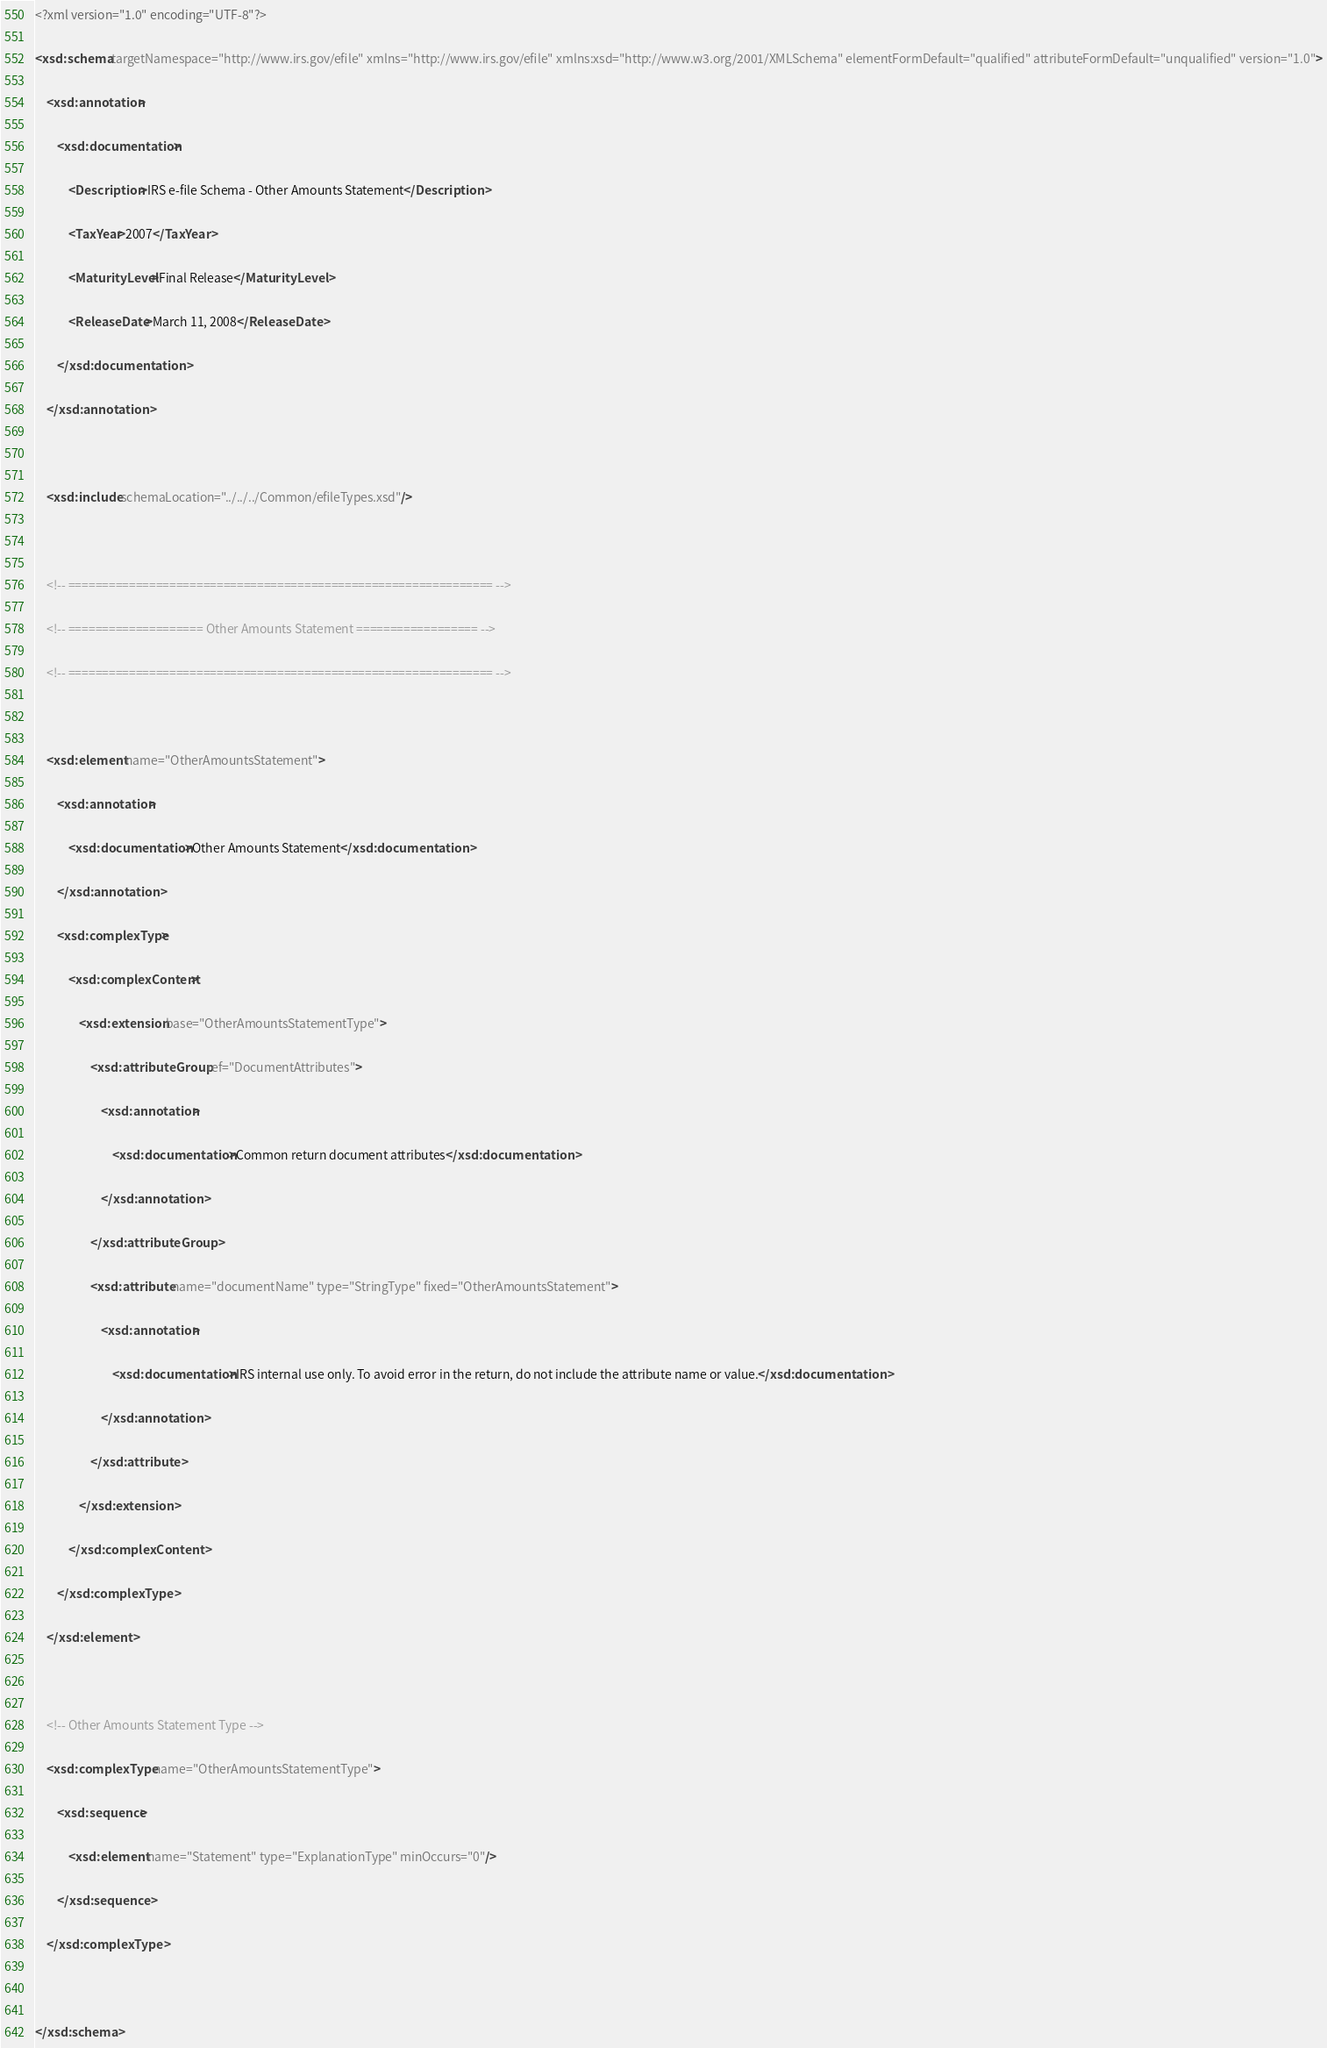<code> <loc_0><loc_0><loc_500><loc_500><_XML_><?xml version="1.0" encoding="UTF-8"?>
<xsd:schema targetNamespace="http://www.irs.gov/efile" xmlns="http://www.irs.gov/efile" xmlns:xsd="http://www.w3.org/2001/XMLSchema" elementFormDefault="qualified" attributeFormDefault="unqualified" version="1.0">
	<xsd:annotation>
		<xsd:documentation>
			<Description>IRS e-file Schema - Other Amounts Statement</Description>
			<TaxYear>2007</TaxYear>
			<MaturityLevel>Final Release</MaturityLevel>
			<ReleaseDate>March 11, 2008</ReleaseDate>
		</xsd:documentation>
	</xsd:annotation>

	<xsd:include schemaLocation="../../../Common/efileTypes.xsd"/>

	<!-- =============================================================== -->
	<!-- ==================== Other Amounts Statement ================== -->
	<!-- =============================================================== -->

	<xsd:element name="OtherAmountsStatement">
		<xsd:annotation>
			<xsd:documentation>Other Amounts Statement</xsd:documentation>
		</xsd:annotation>
		<xsd:complexType>
			<xsd:complexContent>
				<xsd:extension base="OtherAmountsStatementType">
					<xsd:attributeGroup ref="DocumentAttributes">
						<xsd:annotation>
							<xsd:documentation>Common return document attributes</xsd:documentation>
						</xsd:annotation>
					</xsd:attributeGroup>
					<xsd:attribute name="documentName" type="StringType" fixed="OtherAmountsStatement">
						<xsd:annotation>
							<xsd:documentation>IRS internal use only. To avoid error in the return, do not include the attribute name or value.</xsd:documentation>
						</xsd:annotation>
					</xsd:attribute>
				</xsd:extension>
			</xsd:complexContent>
		</xsd:complexType>
	</xsd:element>

	<!-- Other Amounts Statement Type -->
	<xsd:complexType name="OtherAmountsStatementType">
		<xsd:sequence>
			<xsd:element name="Statement" type="ExplanationType" minOccurs="0"/>
		</xsd:sequence>
	</xsd:complexType>

</xsd:schema>
</code> 